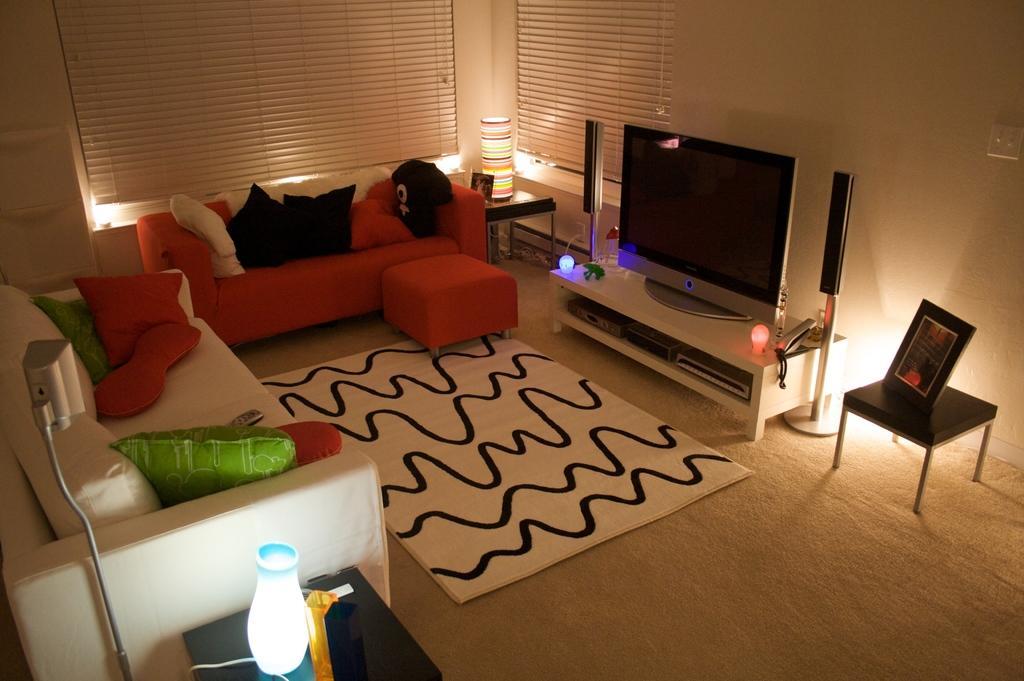Can you describe this image briefly? There are sofas, tables. On the sofa there are pillows. And there is a table. On the table there is a TV, speakers, telephone and lights. Under the TV there is a DVD player. Near the TV there is a table. On the table there is a photo frame. On the corner there is a table lamp. In the background there are curtains. 